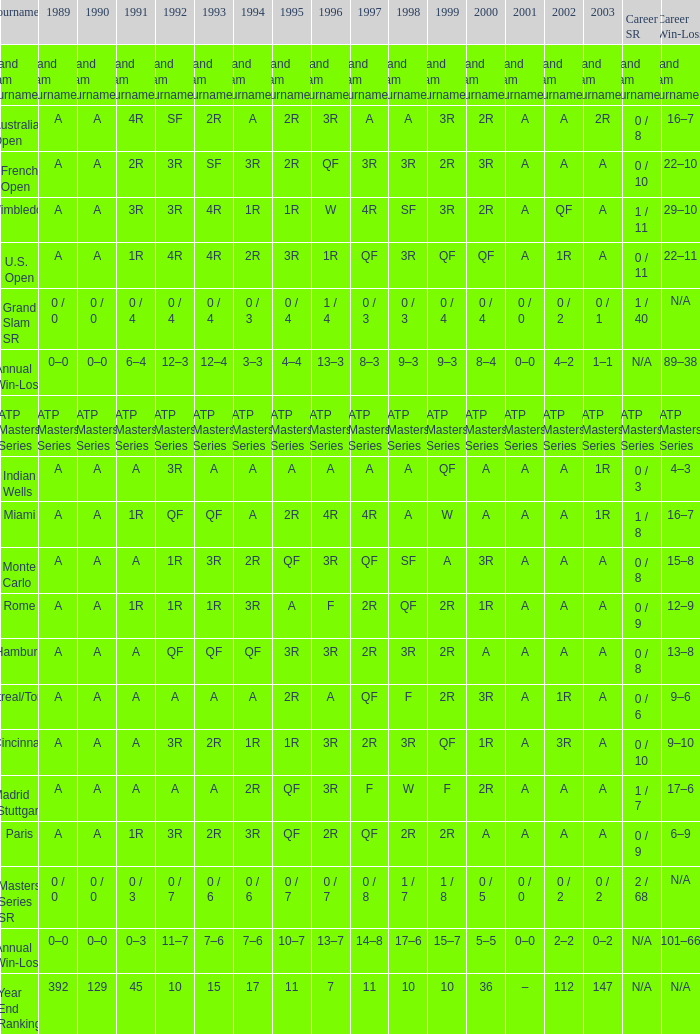What was the 1997 value when 2002 was A and 2003 was 1R? A, 4R. 